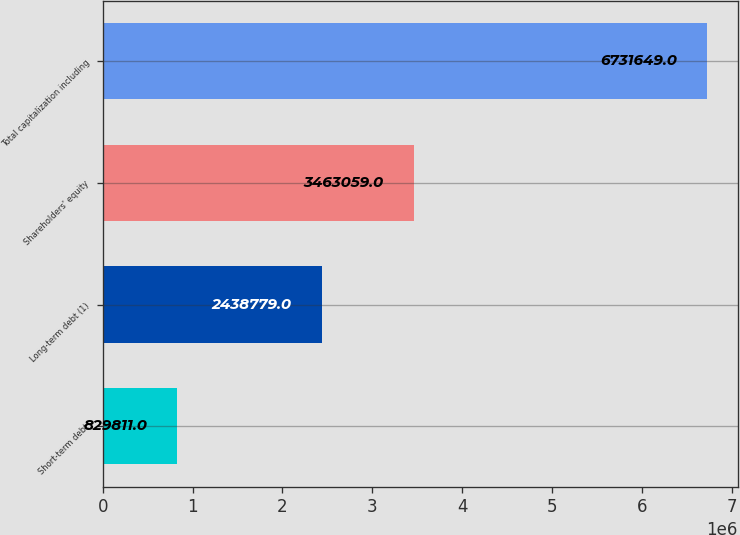<chart> <loc_0><loc_0><loc_500><loc_500><bar_chart><fcel>Short-term debt<fcel>Long-term debt (1)<fcel>Shareholders' equity<fcel>Total capitalization including<nl><fcel>829811<fcel>2.43878e+06<fcel>3.46306e+06<fcel>6.73165e+06<nl></chart> 